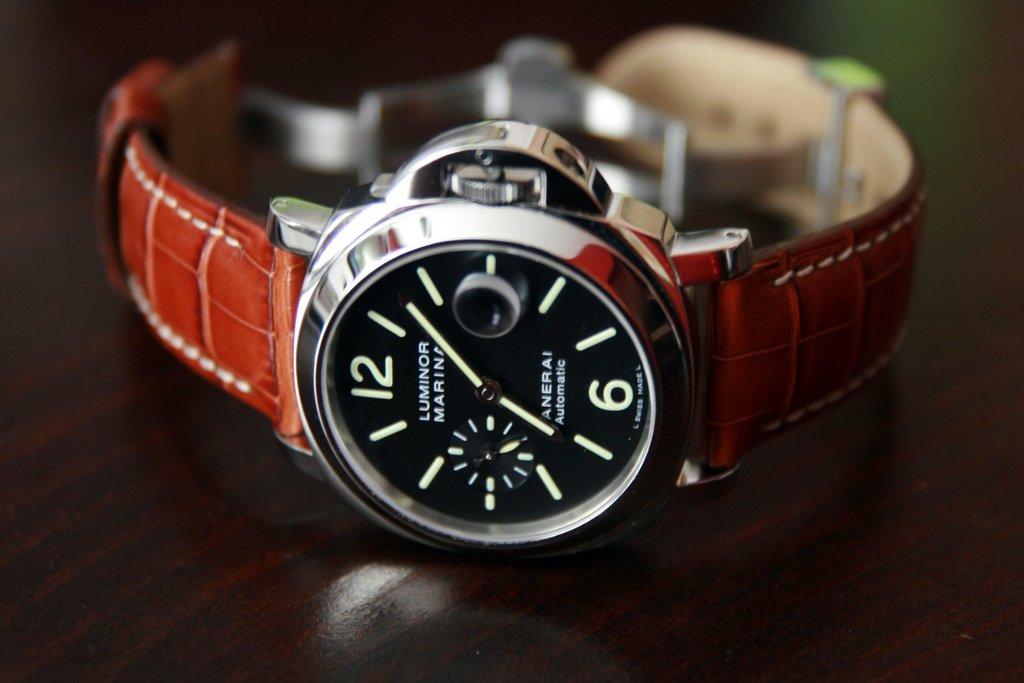What is the time on the clock?
Ensure brevity in your answer.  7:07. What time is shown on the watch?
Your answer should be very brief. 7:07. 